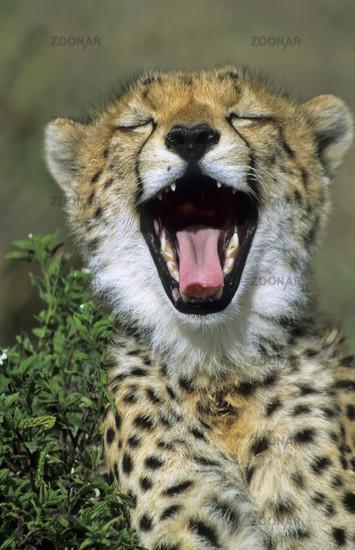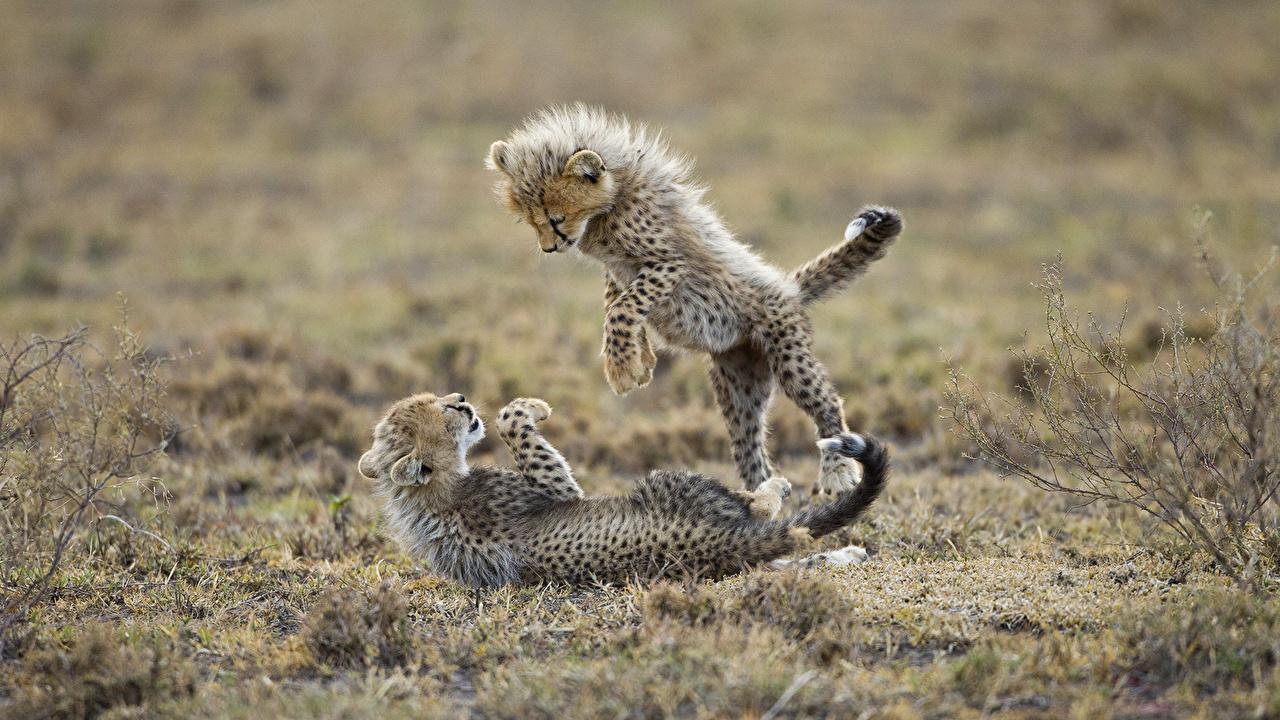The first image is the image on the left, the second image is the image on the right. Examine the images to the left and right. Is the description "A cheetah is yawning." accurate? Answer yes or no. Yes. The first image is the image on the left, the second image is the image on the right. Evaluate the accuracy of this statement regarding the images: "the right pic has two cheetahs". Is it true? Answer yes or no. Yes. 